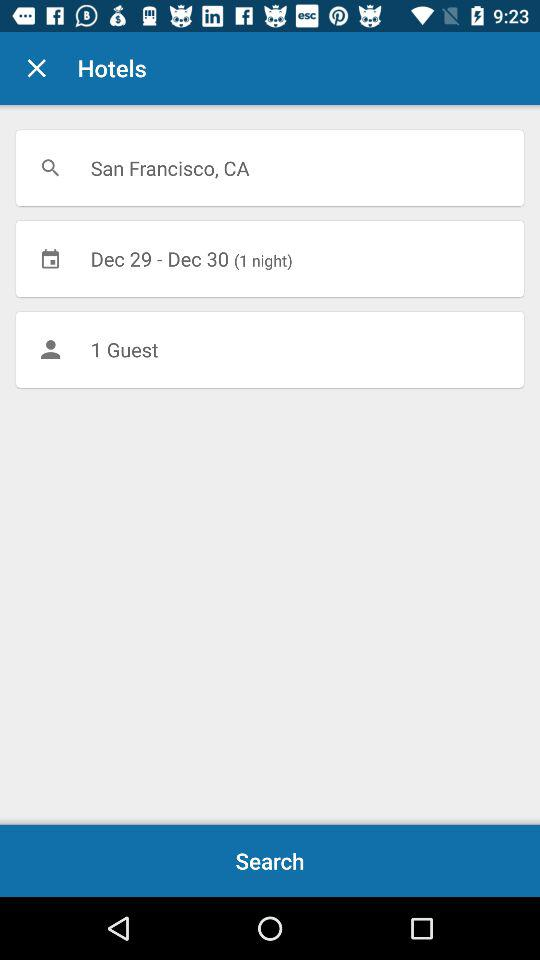For how many guests are hotels being searched? Hotels are being searched for 1 guest. 